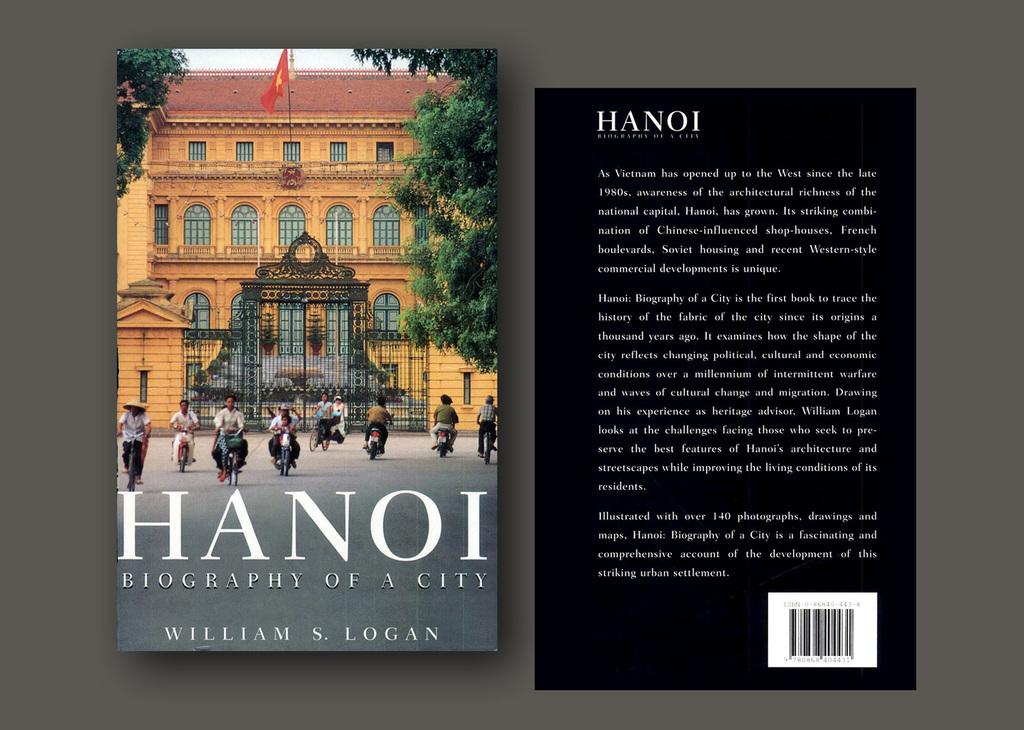What city is this book about?
Offer a very short reply. Hanoi. Who wrote the book hanoi?
Make the answer very short. William s. logan. 